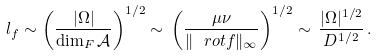<formula> <loc_0><loc_0><loc_500><loc_500>l _ { f } \sim \left ( \frac { | \Omega | } { \dim _ { F } \mathcal { A } } \right ) ^ { 1 / 2 } \sim \, \left ( \frac { \mu \nu } { \| \ r o t f \| _ { \infty } } \right ) ^ { 1 / 2 } \sim \, \frac { | \Omega | ^ { 1 / 2 } } { D ^ { 1 / 2 } } \, .</formula> 